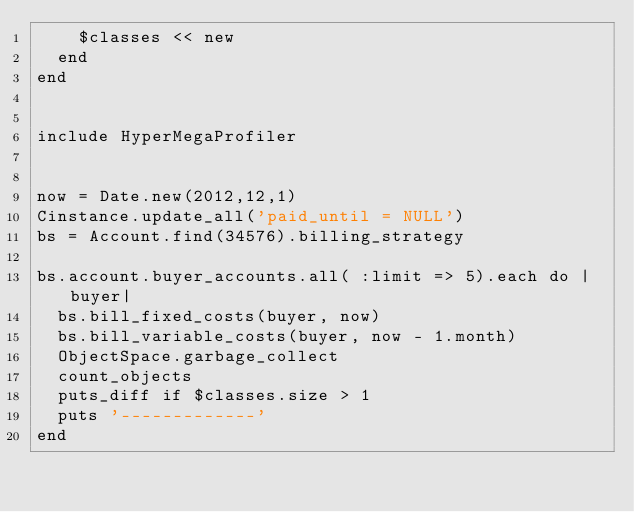<code> <loc_0><loc_0><loc_500><loc_500><_Ruby_>    $classes << new
  end
end


include HyperMegaProfiler


now = Date.new(2012,12,1)
Cinstance.update_all('paid_until = NULL')
bs = Account.find(34576).billing_strategy

bs.account.buyer_accounts.all( :limit => 5).each do |buyer|
  bs.bill_fixed_costs(buyer, now)
  bs.bill_variable_costs(buyer, now - 1.month)
  ObjectSpace.garbage_collect
  count_objects
  puts_diff if $classes.size > 1
  puts '-------------'
end
</code> 